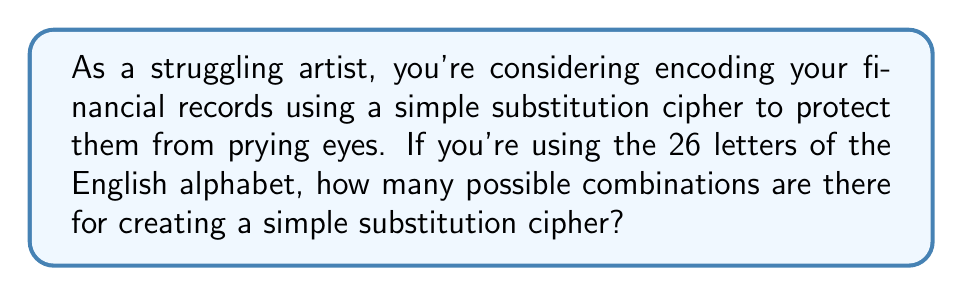Solve this math problem. Let's approach this step-by-step:

1) In a simple substitution cipher, each letter of the alphabet is replaced by another letter, and this replacement is consistent throughout the message.

2) We start with 26 choices for the first letter's replacement:
   $26$ choices

3) For the second letter, we have 25 choices left, as we can't use the letter we used for the first substitution:
   $25$ choices

4) For the third letter, we have 24 choices, and so on.

5) This continues until we've assigned a substitute for all 26 letters.

6) This scenario follows the multiplication principle of counting. We multiply the number of choices for each decision:

   $26 \times 25 \times 24 \times 23 \times ... \times 3 \times 2 \times 1$

7) This is the definition of 26 factorial, written as $26!$

8) We can calculate this:

   $$26! = 403,291,461,126,605,635,584,000,000$$

This incredibly large number represents the total number of possible combinations for a simple substitution cipher using the English alphabet.
Answer: $26!$ or $403,291,461,126,605,635,584,000,000$ 